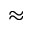Convert formula to latex. <formula><loc_0><loc_0><loc_500><loc_500>\approx</formula> 